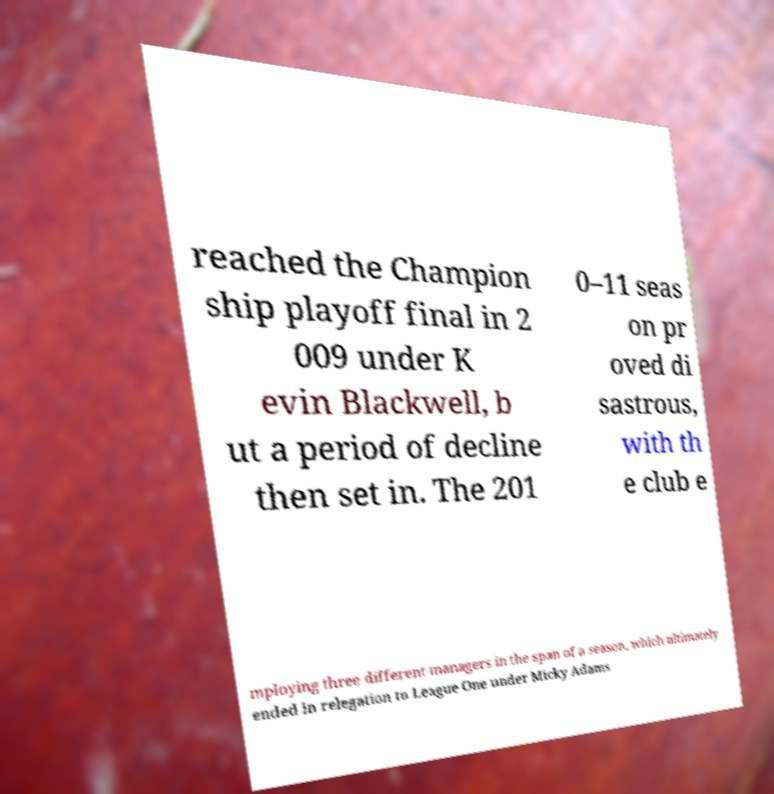For documentation purposes, I need the text within this image transcribed. Could you provide that? reached the Champion ship playoff final in 2 009 under K evin Blackwell, b ut a period of decline then set in. The 201 0–11 seas on pr oved di sastrous, with th e club e mploying three different managers in the span of a season, which ultimately ended in relegation to League One under Micky Adams 